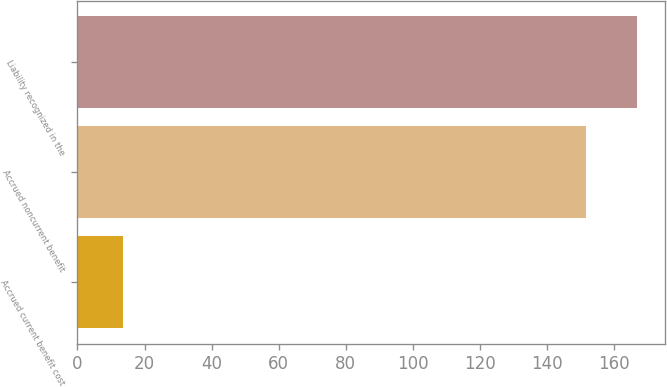Convert chart. <chart><loc_0><loc_0><loc_500><loc_500><bar_chart><fcel>Accrued current benefit cost<fcel>Accrued noncurrent benefit<fcel>Liability recognized in the<nl><fcel>13.6<fcel>151.6<fcel>166.76<nl></chart> 